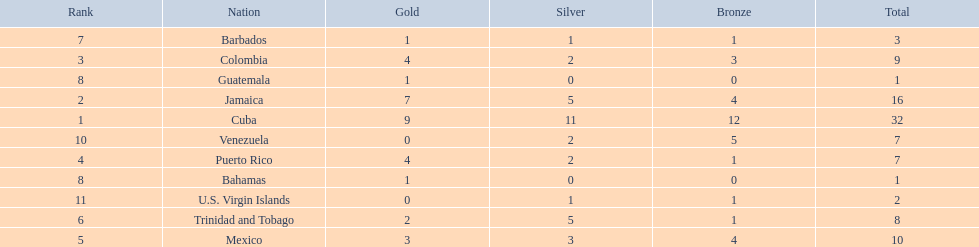Which nations played in the games? Cuba, Jamaica, Colombia, Puerto Rico, Mexico, Trinidad and Tobago, Barbados, Guatemala, Bahamas, Venezuela, U.S. Virgin Islands. Can you give me this table as a dict? {'header': ['Rank', 'Nation', 'Gold', 'Silver', 'Bronze', 'Total'], 'rows': [['7', 'Barbados', '1', '1', '1', '3'], ['3', 'Colombia', '4', '2', '3', '9'], ['8', 'Guatemala', '1', '0', '0', '1'], ['2', 'Jamaica', '7', '5', '4', '16'], ['1', 'Cuba', '9', '11', '12', '32'], ['10', 'Venezuela', '0', '2', '5', '7'], ['4', 'Puerto Rico', '4', '2', '1', '7'], ['8', 'Bahamas', '1', '0', '0', '1'], ['11', 'U.S. Virgin Islands', '0', '1', '1', '2'], ['6', 'Trinidad and Tobago', '2', '5', '1', '8'], ['5', 'Mexico', '3', '3', '4', '10']]} How many silver medals did they win? 11, 5, 2, 2, 3, 5, 1, 0, 0, 2, 1. Which team won the most silver? Cuba. 